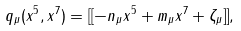<formula> <loc_0><loc_0><loc_500><loc_500>q _ { \mu } ( x ^ { 5 } , x ^ { 7 } ) = [ [ - n _ { \mu } x ^ { 5 } + m _ { \mu } x ^ { 7 } + \zeta _ { \mu } ] ] ,</formula> 